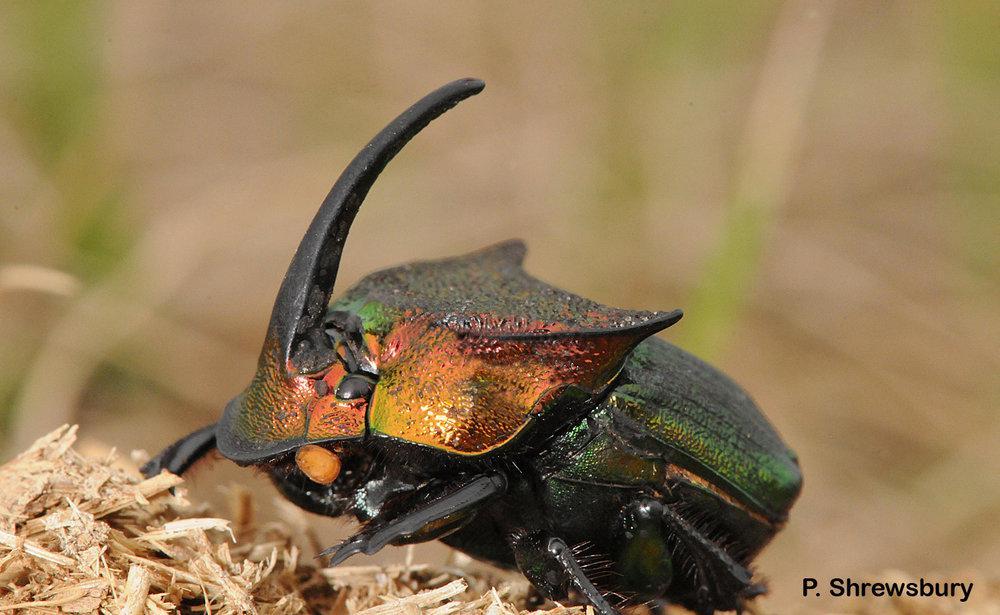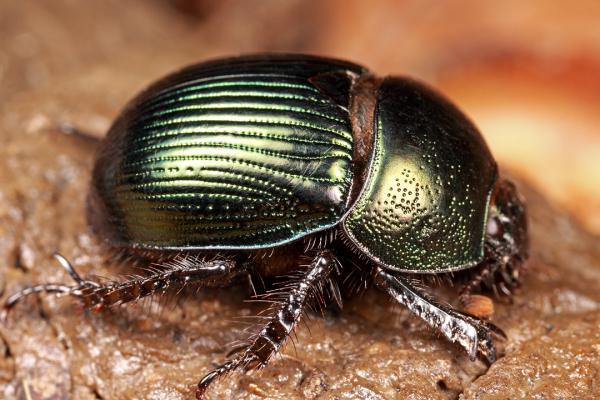The first image is the image on the left, the second image is the image on the right. Examine the images to the left and right. Is the description "There are two dogs standing in the dirt in one of the images." accurate? Answer yes or no. No. The first image is the image on the left, the second image is the image on the right. Analyze the images presented: Is the assertion "There are two beetles touching a dungball." valid? Answer yes or no. No. 